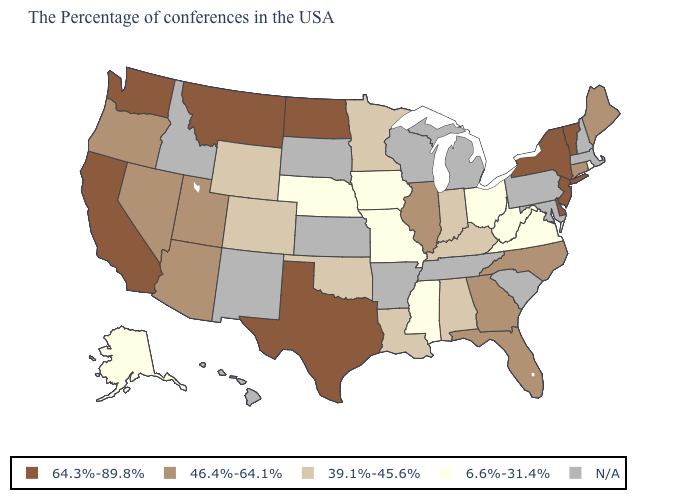Does Alaska have the highest value in the USA?
Short answer required. No. What is the value of Maryland?
Give a very brief answer. N/A. What is the value of Pennsylvania?
Quick response, please. N/A. What is the value of Michigan?
Be succinct. N/A. What is the lowest value in states that border Arkansas?
Short answer required. 6.6%-31.4%. Name the states that have a value in the range 39.1%-45.6%?
Concise answer only. Kentucky, Indiana, Alabama, Louisiana, Minnesota, Oklahoma, Wyoming, Colorado. What is the value of Kansas?
Give a very brief answer. N/A. Name the states that have a value in the range 64.3%-89.8%?
Answer briefly. Vermont, New York, New Jersey, Delaware, Texas, North Dakota, Montana, California, Washington. Does North Dakota have the highest value in the MidWest?
Give a very brief answer. Yes. Does the first symbol in the legend represent the smallest category?
Keep it brief. No. What is the value of Colorado?
Keep it brief. 39.1%-45.6%. Name the states that have a value in the range N/A?
Quick response, please. Massachusetts, New Hampshire, Maryland, Pennsylvania, South Carolina, Michigan, Tennessee, Wisconsin, Arkansas, Kansas, South Dakota, New Mexico, Idaho, Hawaii. Name the states that have a value in the range 64.3%-89.8%?
Quick response, please. Vermont, New York, New Jersey, Delaware, Texas, North Dakota, Montana, California, Washington. What is the value of South Dakota?
Short answer required. N/A. 